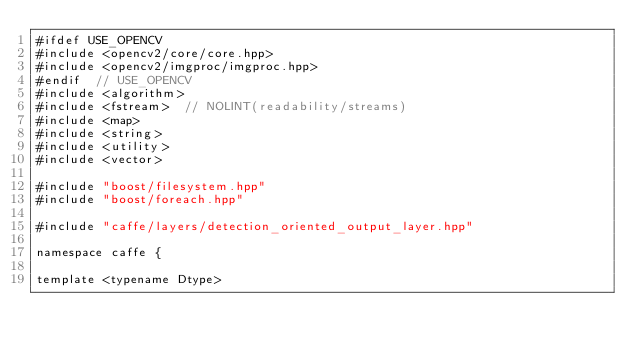<code> <loc_0><loc_0><loc_500><loc_500><_Cuda_>#ifdef USE_OPENCV
#include <opencv2/core/core.hpp>
#include <opencv2/imgproc/imgproc.hpp>
#endif  // USE_OPENCV
#include <algorithm>
#include <fstream>  // NOLINT(readability/streams)
#include <map>
#include <string>
#include <utility>
#include <vector>

#include "boost/filesystem.hpp"
#include "boost/foreach.hpp"

#include "caffe/layers/detection_oriented_output_layer.hpp"

namespace caffe {

template <typename Dtype></code> 